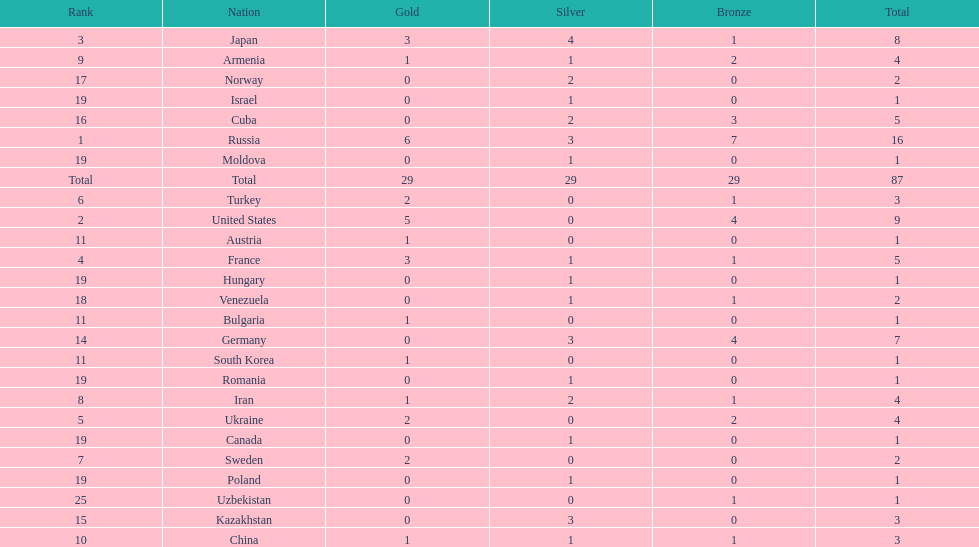What were the nations that participated in the 1995 world wrestling championships? Russia, United States, Japan, France, Ukraine, Turkey, Sweden, Iran, Armenia, China, Austria, Bulgaria, South Korea, Germany, Kazakhstan, Cuba, Norway, Venezuela, Canada, Hungary, Israel, Moldova, Poland, Romania, Uzbekistan. How many gold medals did the united states earn in the championship? 5. What amount of medals earner was greater than this value? 6. What country earned these medals? Russia. 